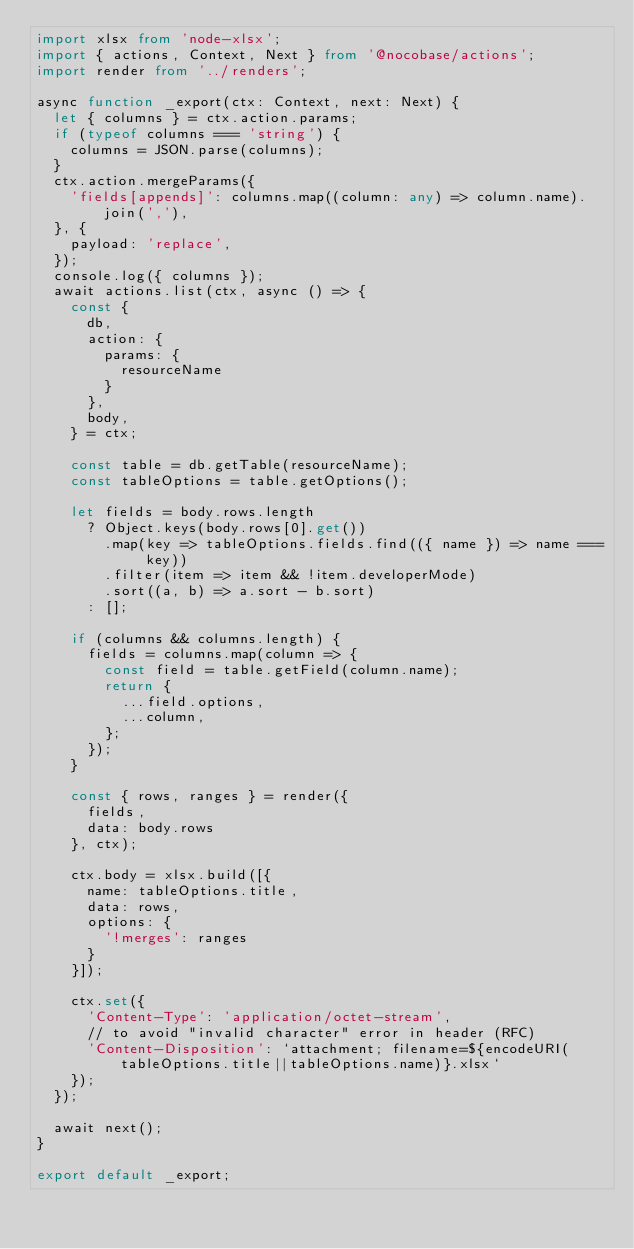Convert code to text. <code><loc_0><loc_0><loc_500><loc_500><_TypeScript_>import xlsx from 'node-xlsx';
import { actions, Context, Next } from '@nocobase/actions';
import render from '../renders';

async function _export(ctx: Context, next: Next) {
  let { columns } = ctx.action.params;
  if (typeof columns === 'string') {
    columns = JSON.parse(columns);
  }
  ctx.action.mergeParams({
    'fields[appends]': columns.map((column: any) => column.name).join(','),
  }, {
    payload: 'replace',
  });
  console.log({ columns });
  await actions.list(ctx, async () => {
    const {
      db,
      action: {
        params: {
          resourceName
        }
      },
      body,
    } = ctx;

    const table = db.getTable(resourceName);
    const tableOptions = table.getOptions();

    let fields = body.rows.length
      ? Object.keys(body.rows[0].get())
        .map(key => tableOptions.fields.find(({ name }) => name === key))
        .filter(item => item && !item.developerMode)
        .sort((a, b) => a.sort - b.sort)
      : [];

    if (columns && columns.length) {
      fields = columns.map(column => {
        const field = table.getField(column.name);
        return {
          ...field.options,
          ...column,
        };
      });
    }

    const { rows, ranges } = render({
      fields,
      data: body.rows
    }, ctx);

    ctx.body = xlsx.build([{
      name: tableOptions.title,
      data: rows,
      options: {
        '!merges': ranges
      }
    }]);

    ctx.set({
      'Content-Type': 'application/octet-stream',
      // to avoid "invalid character" error in header (RFC)
      'Content-Disposition': `attachment; filename=${encodeURI(tableOptions.title||tableOptions.name)}.xlsx`
    });
  });

  await next();
}

export default _export;
</code> 